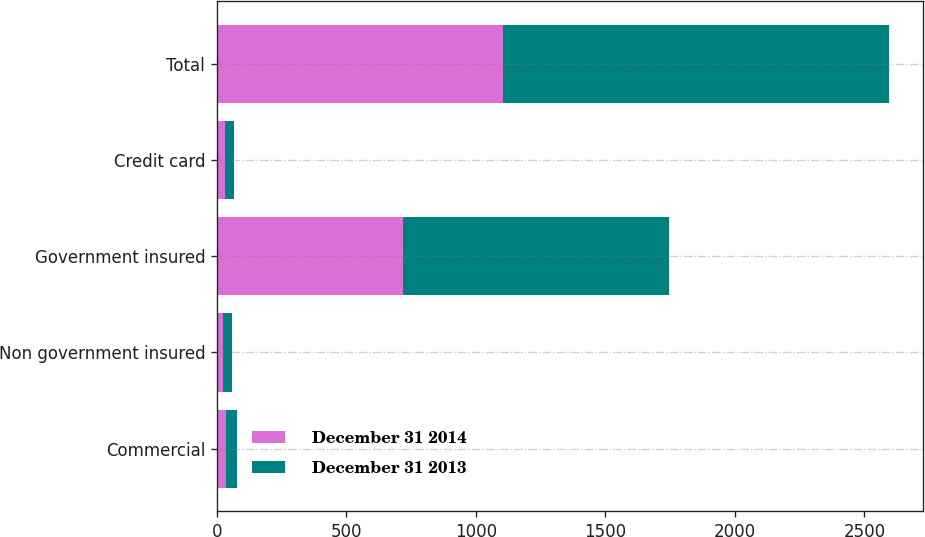Convert chart to OTSL. <chart><loc_0><loc_0><loc_500><loc_500><stacked_bar_chart><ecel><fcel>Commercial<fcel>Non government insured<fcel>Government insured<fcel>Credit card<fcel>Total<nl><fcel>December 31 2014<fcel>37<fcel>23<fcel>719<fcel>33<fcel>1105<nl><fcel>December 31 2013<fcel>42<fcel>35<fcel>1025<fcel>34<fcel>1491<nl></chart> 